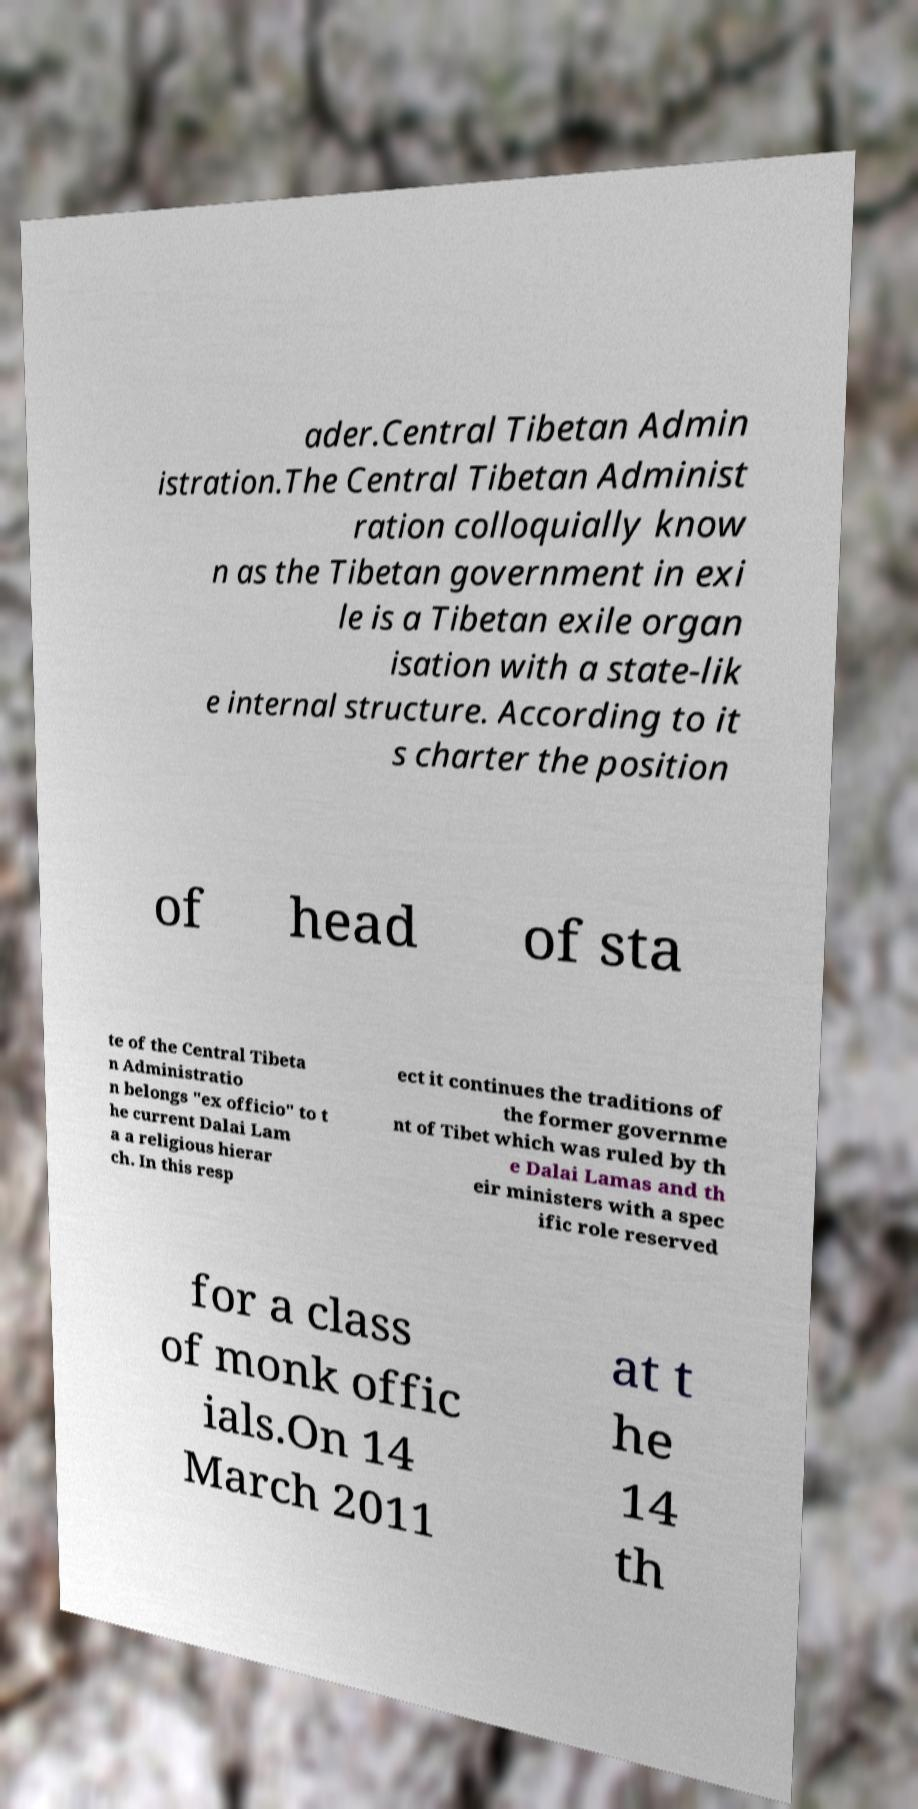Can you accurately transcribe the text from the provided image for me? ader.Central Tibetan Admin istration.The Central Tibetan Administ ration colloquially know n as the Tibetan government in exi le is a Tibetan exile organ isation with a state-lik e internal structure. According to it s charter the position of head of sta te of the Central Tibeta n Administratio n belongs "ex officio" to t he current Dalai Lam a a religious hierar ch. In this resp ect it continues the traditions of the former governme nt of Tibet which was ruled by th e Dalai Lamas and th eir ministers with a spec ific role reserved for a class of monk offic ials.On 14 March 2011 at t he 14 th 